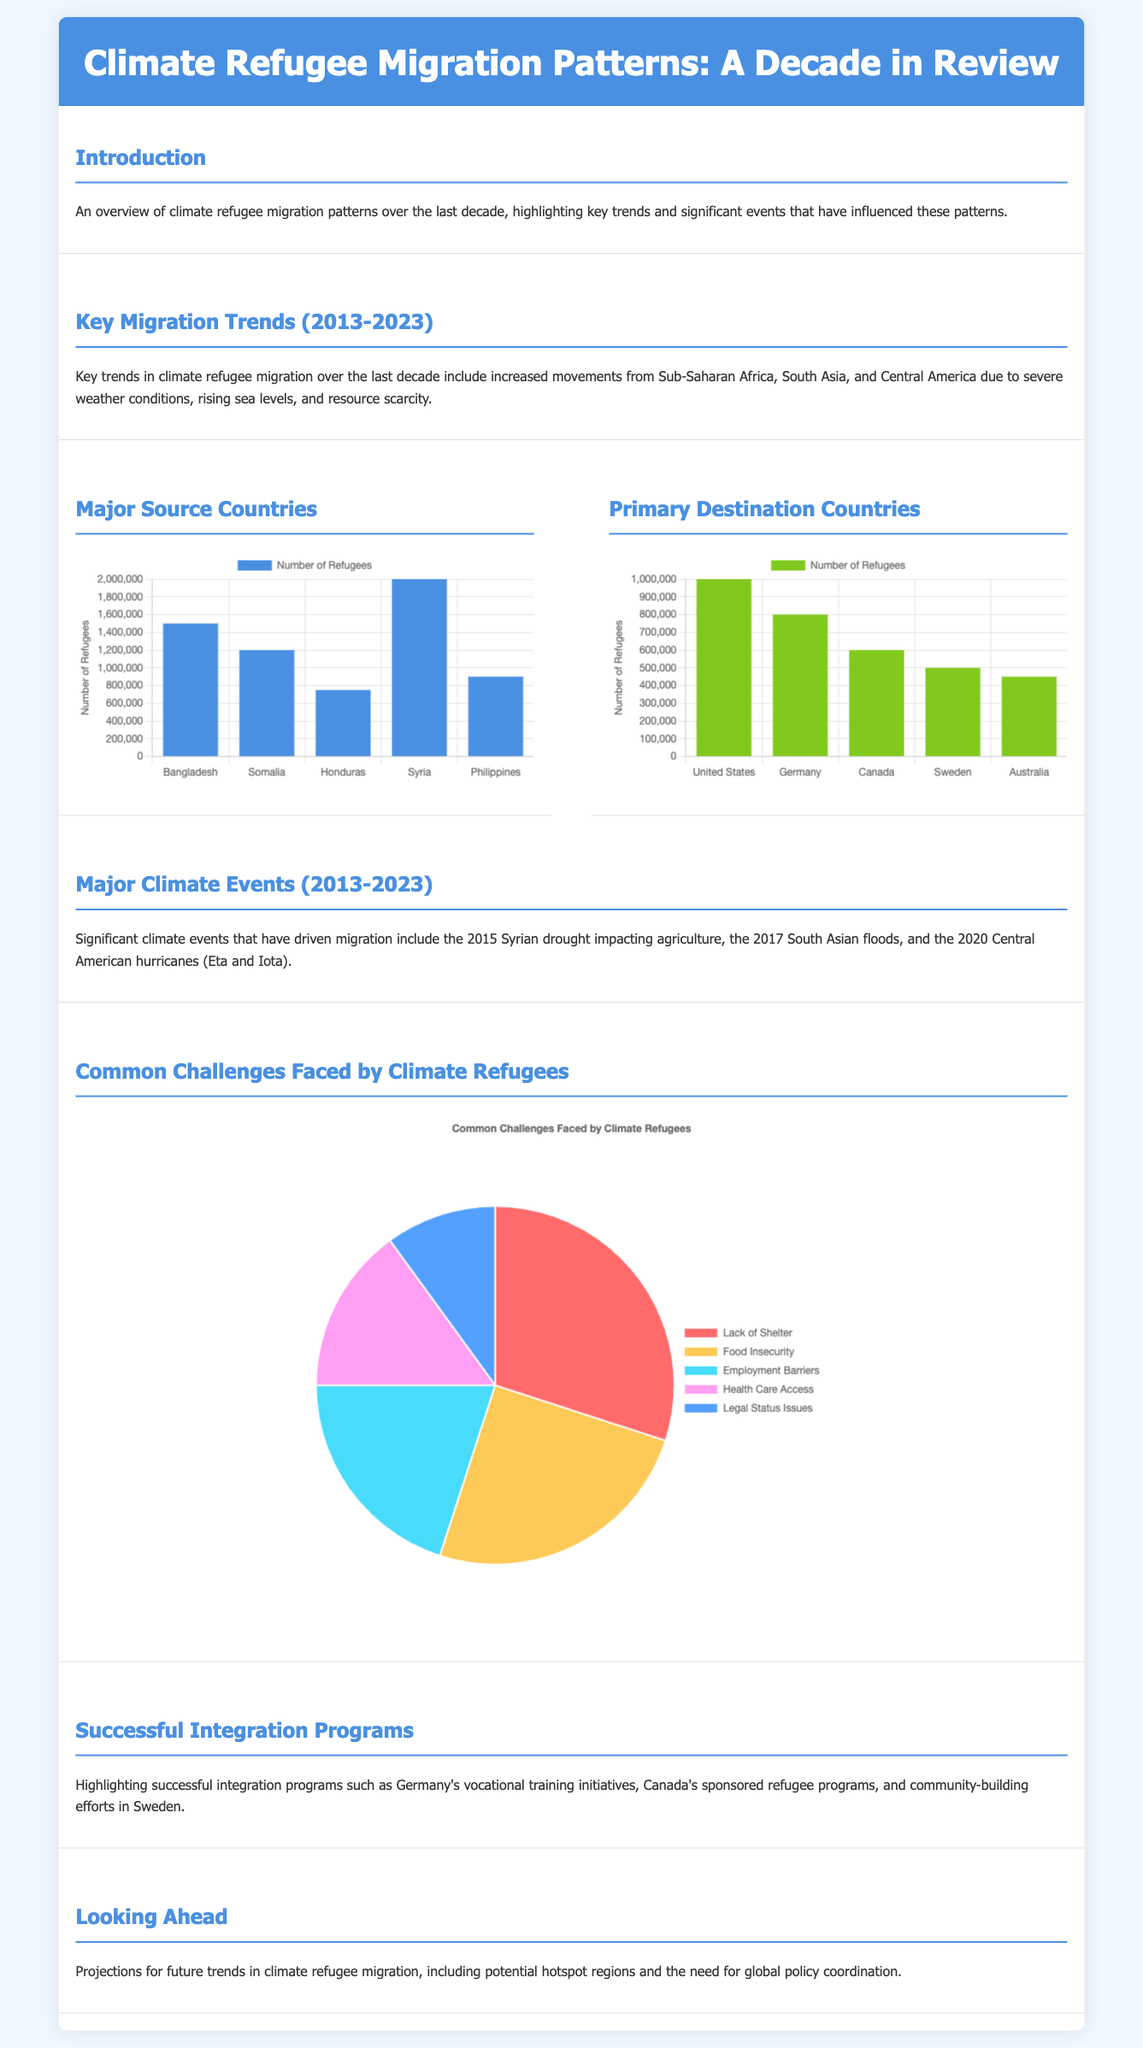What is the title of the infographic? The title of the infographic is prominently displayed at the top and provides an overview of the subject matter.
Answer: Climate Refugee Migration Patterns: A Decade in Review Which country has the highest number of refugees? The bar chart representing major source countries shows the number of refugees, with Bangladesh having the highest figure.
Answer: Bangladesh What trend is highlighted in the key migration trends section? The section discusses significant trends related to migration influenced by climate factors over the last decade.
Answer: Increased movements from Sub-Saharan Africa What is the total number of refugees from Syria? The chart for source countries indicates that Syria has a specific number of refugees represented in the document.
Answer: 2000000 Which country received the most climate refugees? The bar chart for primary destination countries indicates the country with the highest number of incoming refugees.
Answer: United States What percentage of climate refugees face food insecurity? The pie chart presents various challenges faced by climate refugees, highlighting the specific issue of food insecurity.
Answer: 25 Name a successful integration program mentioned in the document. The document lists specific programs aimed at integrating climate refugees successfully in host countries.
Answer: Germany's vocational training initiatives What year did the significant South Asian floods occur? The document describes major climate events in a timeline, pointing out a specific year for this event.
Answer: 2017 Which challenge has the least impact on climate refugees, according to the chart? The pie chart illustrates the typical challenges faced by refugees and indicates the least significant one.
Answer: Legal Status Issues 